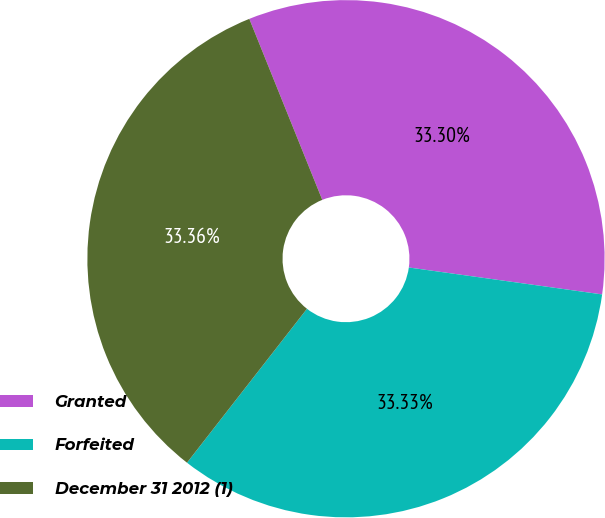Convert chart to OTSL. <chart><loc_0><loc_0><loc_500><loc_500><pie_chart><fcel>Granted<fcel>Forfeited<fcel>December 31 2012 (1)<nl><fcel>33.3%<fcel>33.33%<fcel>33.36%<nl></chart> 